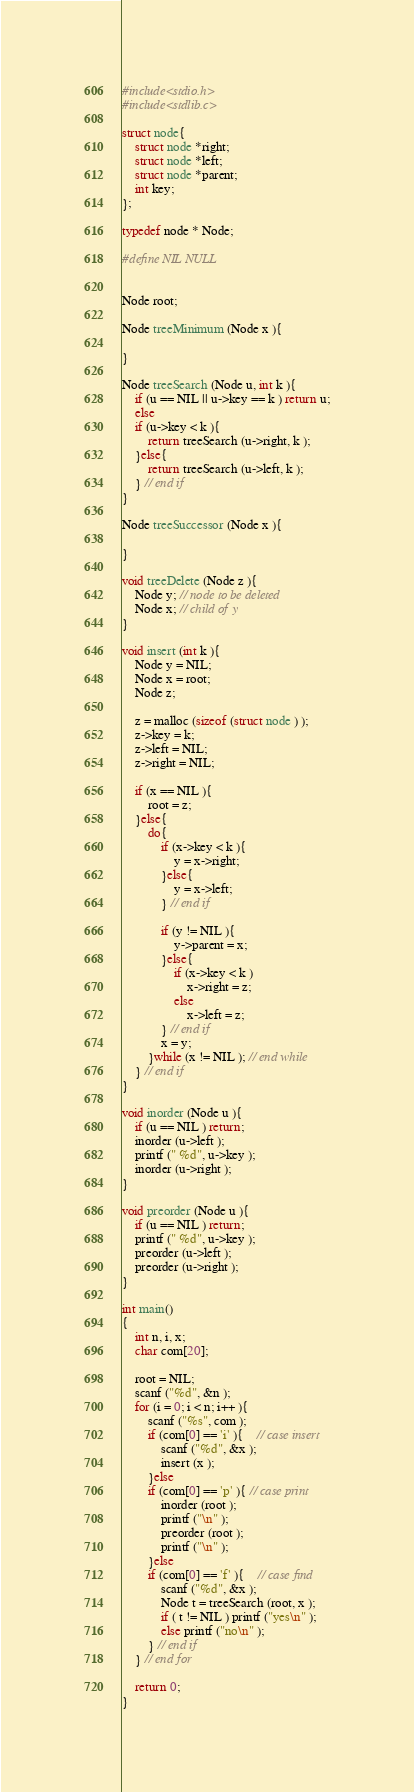Convert code to text. <code><loc_0><loc_0><loc_500><loc_500><_C_>#include<stdio.h>
#include<stdlib.c>

struct node{
	struct node *right;
	struct node *left;
	struct node *parent;
	int key;
};

typedef node * Node;

#define NIL NULL


Node root;
 
Node treeMinimum (Node x ){
 
}
 
Node treeSearch (Node u, int k ){
    if (u == NIL || u->key == k ) return u;
    else
    if (u->key < k ){
        return treeSearch (u->right, k );
    }else{
        return treeSearch (u->left, k );
    } // end if 
}
 
Node treeSuccessor (Node x ){
 
}
 
void treeDelete (Node z ){
    Node y; // node to be deleted
    Node x; // child of y
}
 
void insert (int k ){
    Node y = NIL;
    Node x = root;
    Node z;
 
    z = malloc (sizeof (struct node ) );
    z->key = k;
    z->left = NIL;
    z->right = NIL;
 
    if (x == NIL ){
        root = z;
    }else{
        do{
            if (x->key < k ){
                y = x->right;
            }else{
                y = x->left;
            } // end if
 
            if (y != NIL ){
                y->parent = x;
            }else{
                if (x->key < k )
                    x->right = z;
                else
                    x->left = z;
            } // end if
            x = y;
        }while (x != NIL ); // end while
    } // end if
}
 
void inorder (Node u ){
    if (u == NIL ) return;
    inorder (u->left );
    printf (" %d", u->key );
    inorder (u->right );
}
 
void preorder (Node u ){
    if (u == NIL ) return;
    printf (" %d", u->key );
    preorder (u->left );
    preorder (u->right );
}
 
int main()
{
    int n, i, x;
    char com[20];
 
    root = NIL;
    scanf ("%d", &n );
    for (i = 0; i < n; i++ ){
        scanf ("%s", com );
        if (com[0] == 'i' ){    // case insert 
            scanf ("%d", &x );
            insert (x );
        }else
        if (com[0] == 'p' ){ // case print
            inorder (root );
            printf ("\n" );
            preorder (root );
            printf ("\n" );
        }else
        if (com[0] == 'f' ){    // case find
            scanf ("%d", &x );
            Node t = treeSearch (root, x );
            if ( t != NIL ) printf ("yes\n" );
            else printf ("no\n" );
        } // end if
    } // end for
 
    return 0;
}
</code> 